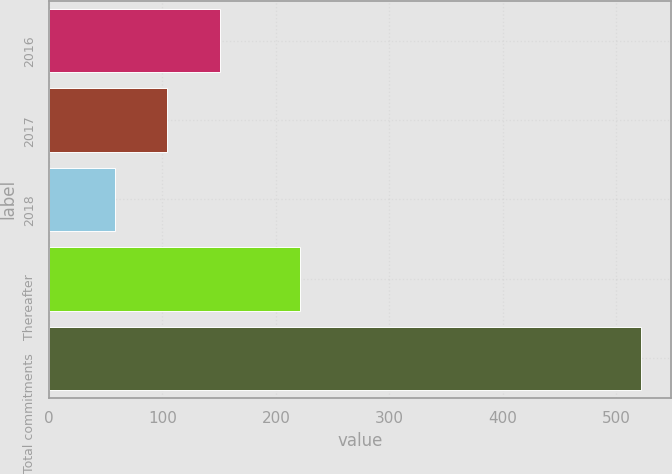Convert chart to OTSL. <chart><loc_0><loc_0><loc_500><loc_500><bar_chart><fcel>2016<fcel>2017<fcel>2018<fcel>Thereafter<fcel>Total commitments<nl><fcel>150.8<fcel>104.4<fcel>58<fcel>221<fcel>522<nl></chart> 